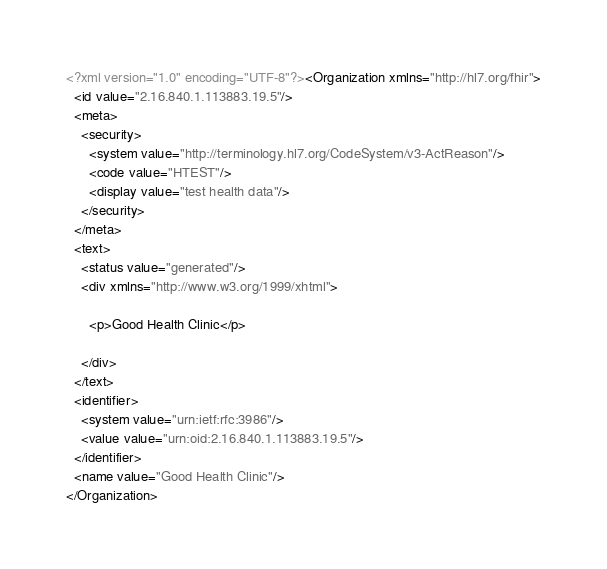Convert code to text. <code><loc_0><loc_0><loc_500><loc_500><_XML_><?xml version="1.0" encoding="UTF-8"?><Organization xmlns="http://hl7.org/fhir">
  <id value="2.16.840.1.113883.19.5"/>
  <meta>
    <security>
      <system value="http://terminology.hl7.org/CodeSystem/v3-ActReason"/>
      <code value="HTEST"/>
      <display value="test health data"/>
    </security>
  </meta>
  <text>
    <status value="generated"/>
    <div xmlns="http://www.w3.org/1999/xhtml">
      
      <p>Good Health Clinic</p>
    
    </div>
  </text>
  <identifier>
    <system value="urn:ietf:rfc:3986"/>
    <value value="urn:oid:2.16.840.1.113883.19.5"/>
  </identifier>
  <name value="Good Health Clinic"/>
</Organization></code> 